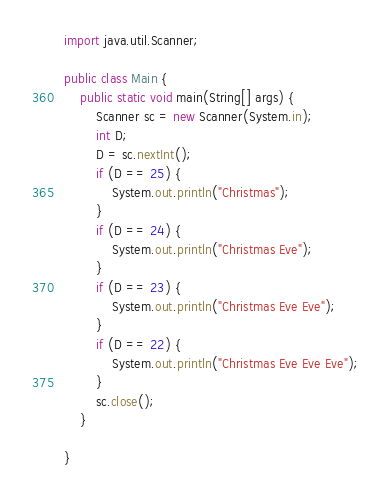<code> <loc_0><loc_0><loc_500><loc_500><_Java_>import java.util.Scanner;

public class Main {
	public static void main(String[] args) {
		Scanner sc = new Scanner(System.in);
		int D;
		D = sc.nextInt();
		if (D == 25) {
			System.out.println("Christmas");
		}
		if (D == 24) {
			System.out.println("Christmas Eve");
		}
		if (D == 23) {
			System.out.println("Christmas Eve Eve");
		}
		if (D == 22) {
			System.out.println("Christmas Eve Eve Eve");
		}
		sc.close();
	}

}
</code> 